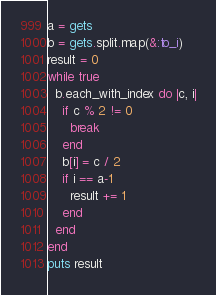Convert code to text. <code><loc_0><loc_0><loc_500><loc_500><_Ruby_>a = gets
b = gets.split.map(&:to_i)
result = 0
while true
  b.each_with_index do |c, i|
    if c % 2 != 0
      break
    end
    b[i] = c / 2
    if i == a-1
      result += 1
    end
  end
end
puts result</code> 